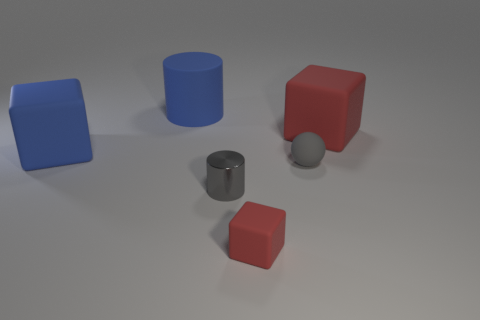Subtract all blue cylinders. How many red blocks are left? 2 Subtract all large cubes. How many cubes are left? 1 Add 1 big blue matte cubes. How many objects exist? 7 Subtract all balls. How many objects are left? 5 Subtract all large matte cubes. Subtract all tiny gray metallic cylinders. How many objects are left? 3 Add 5 small matte things. How many small matte things are left? 7 Add 6 gray matte spheres. How many gray matte spheres exist? 7 Subtract 2 red cubes. How many objects are left? 4 